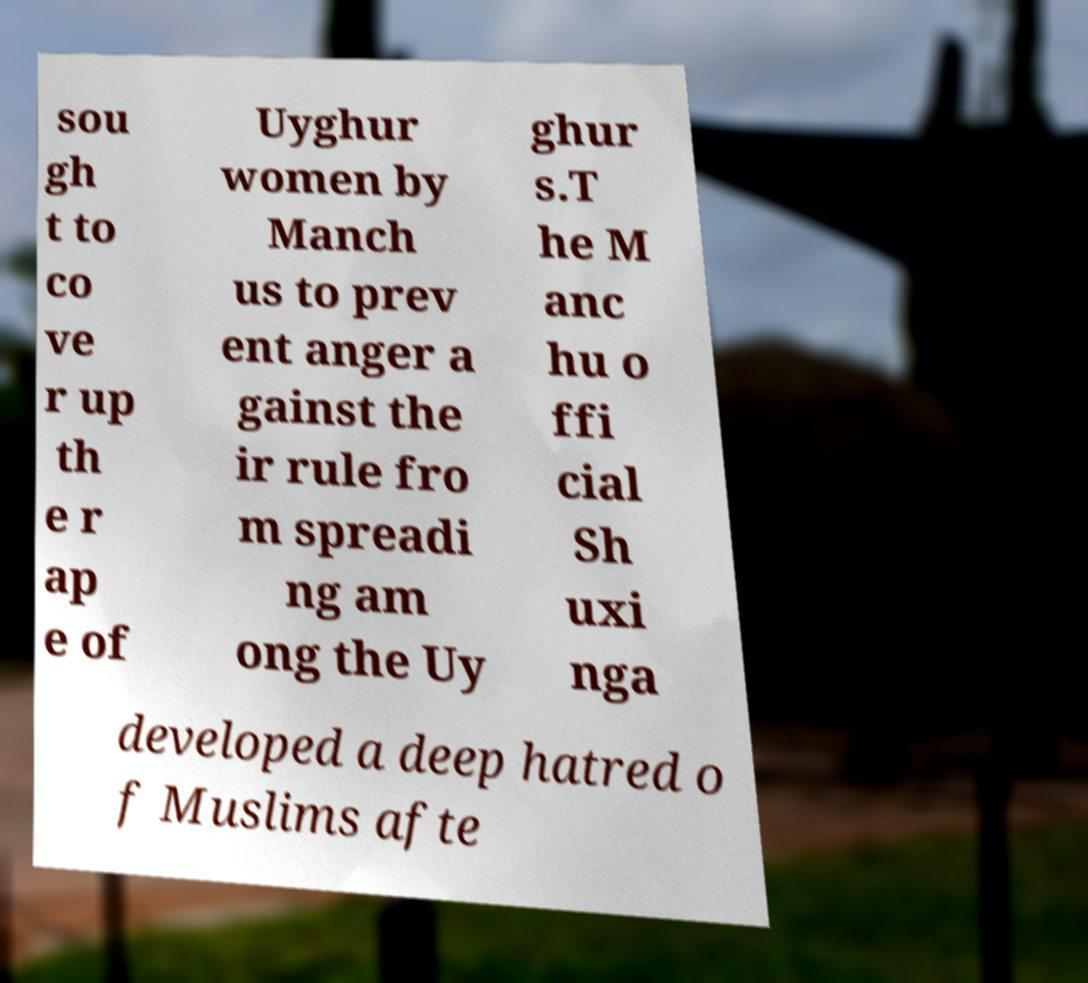I need the written content from this picture converted into text. Can you do that? sou gh t to co ve r up th e r ap e of Uyghur women by Manch us to prev ent anger a gainst the ir rule fro m spreadi ng am ong the Uy ghur s.T he M anc hu o ffi cial Sh uxi nga developed a deep hatred o f Muslims afte 